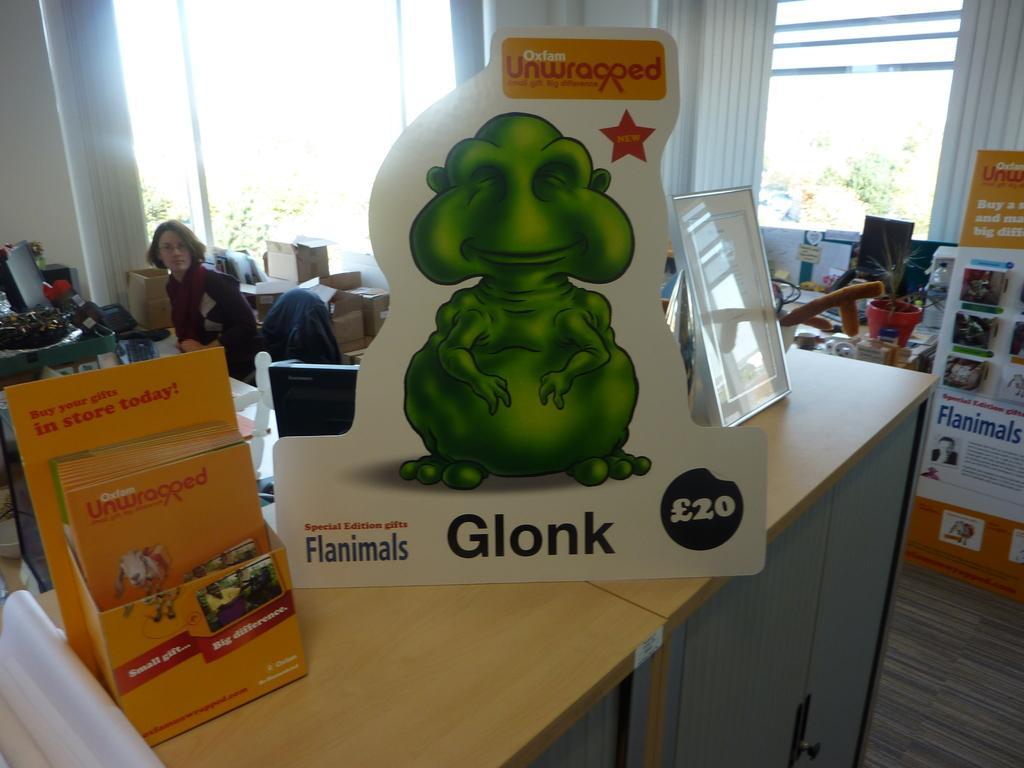Can you describe this image briefly? In this image, we can see the board, frame and box with few objects are on the cupboards. Background we can see carton boxes, person, house plant with pot, walls, window shades, glass objects and few things. On the right side of the image, we can see a banner on the path. 